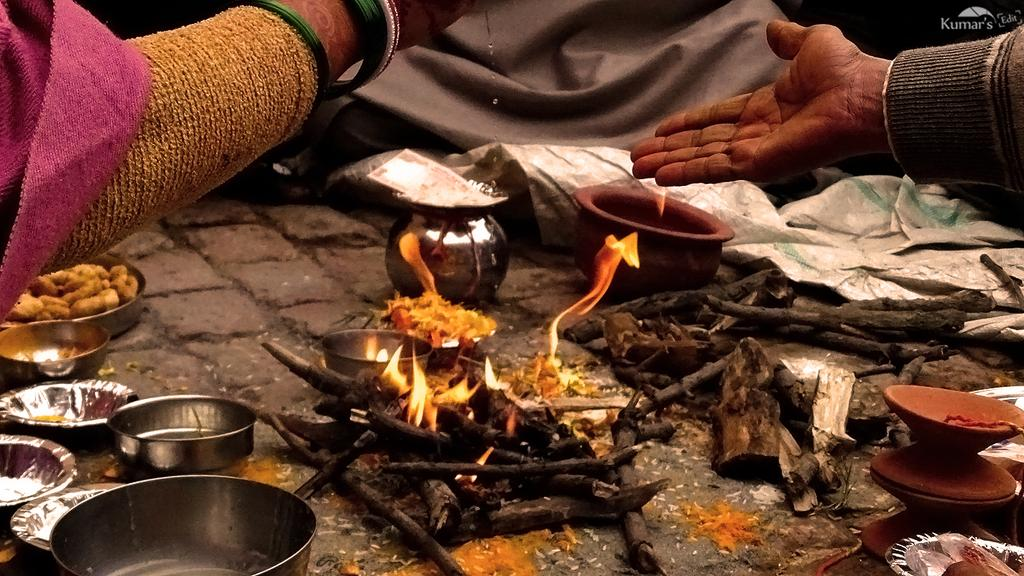What type of bowls are in the image? There are steel bowls in the image. What else can be seen in the image besides the bowls? Money, wooden sticks, fire, pots on the floor, a woman's hand and bangles, and a man's hand are visible in the image. What might be used to stir or mix something in the image? The wooden sticks in the image might be used to stir or mix something. What is the woman's hand holding in the image? It is not clear what the woman's hand is holding, but her bangles are visible. What type of cannon is being fired in the image? There is no cannon present in the image. What type of dress is the woman wearing in the image? It is not clear what the woman is wearing, as only her hand and bangles are visible in the image. 